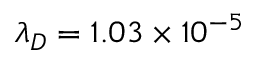Convert formula to latex. <formula><loc_0><loc_0><loc_500><loc_500>{ \lambda } _ { D } = 1 . 0 3 \times 1 0 ^ { - 5 }</formula> 